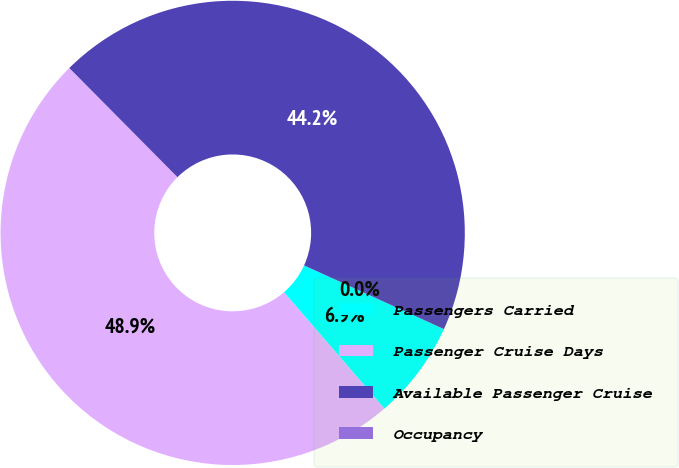Convert chart. <chart><loc_0><loc_0><loc_500><loc_500><pie_chart><fcel>Passengers Carried<fcel>Passenger Cruise Days<fcel>Available Passenger Cruise<fcel>Occupancy<nl><fcel>6.87%<fcel>48.9%<fcel>44.23%<fcel>0.0%<nl></chart> 